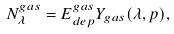<formula> <loc_0><loc_0><loc_500><loc_500>N _ { \lambda } ^ { g a s } = E _ { d e p } ^ { g a s } Y _ { g a s } ( \lambda , p ) ,</formula> 